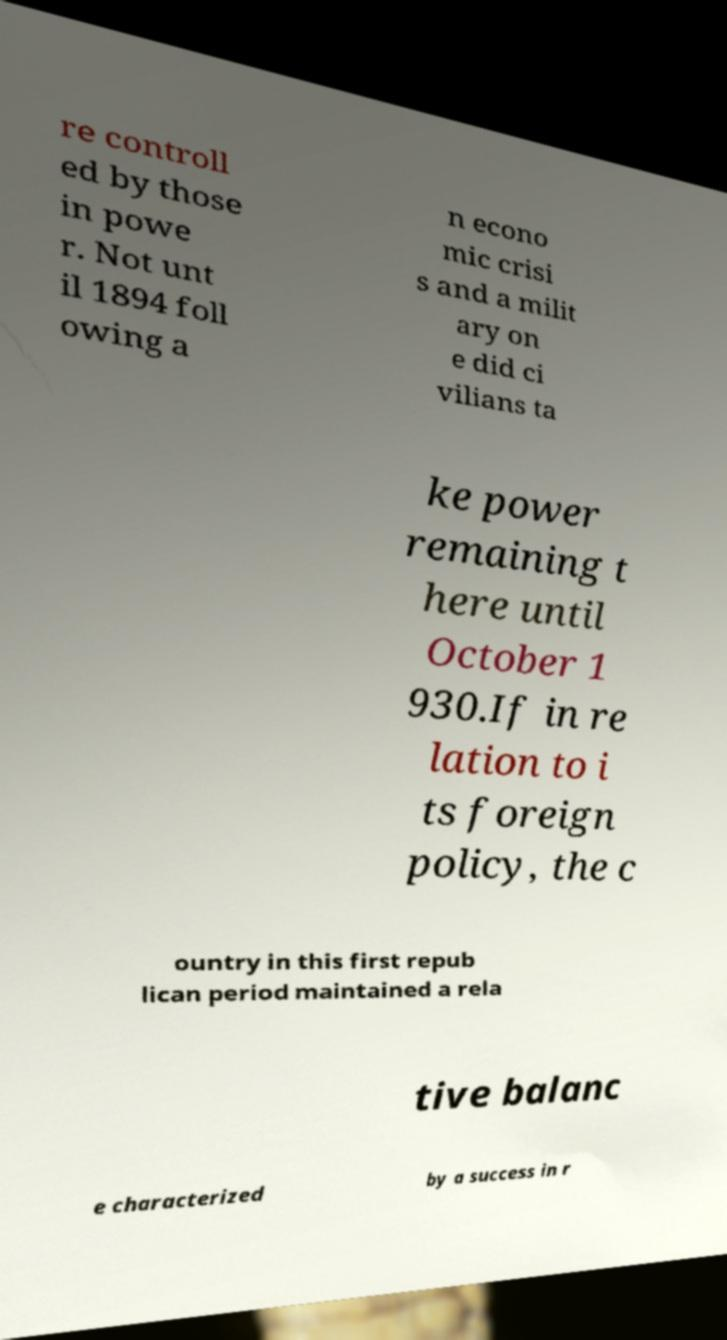Can you read and provide the text displayed in the image?This photo seems to have some interesting text. Can you extract and type it out for me? re controll ed by those in powe r. Not unt il 1894 foll owing a n econo mic crisi s and a milit ary on e did ci vilians ta ke power remaining t here until October 1 930.If in re lation to i ts foreign policy, the c ountry in this first repub lican period maintained a rela tive balanc e characterized by a success in r 